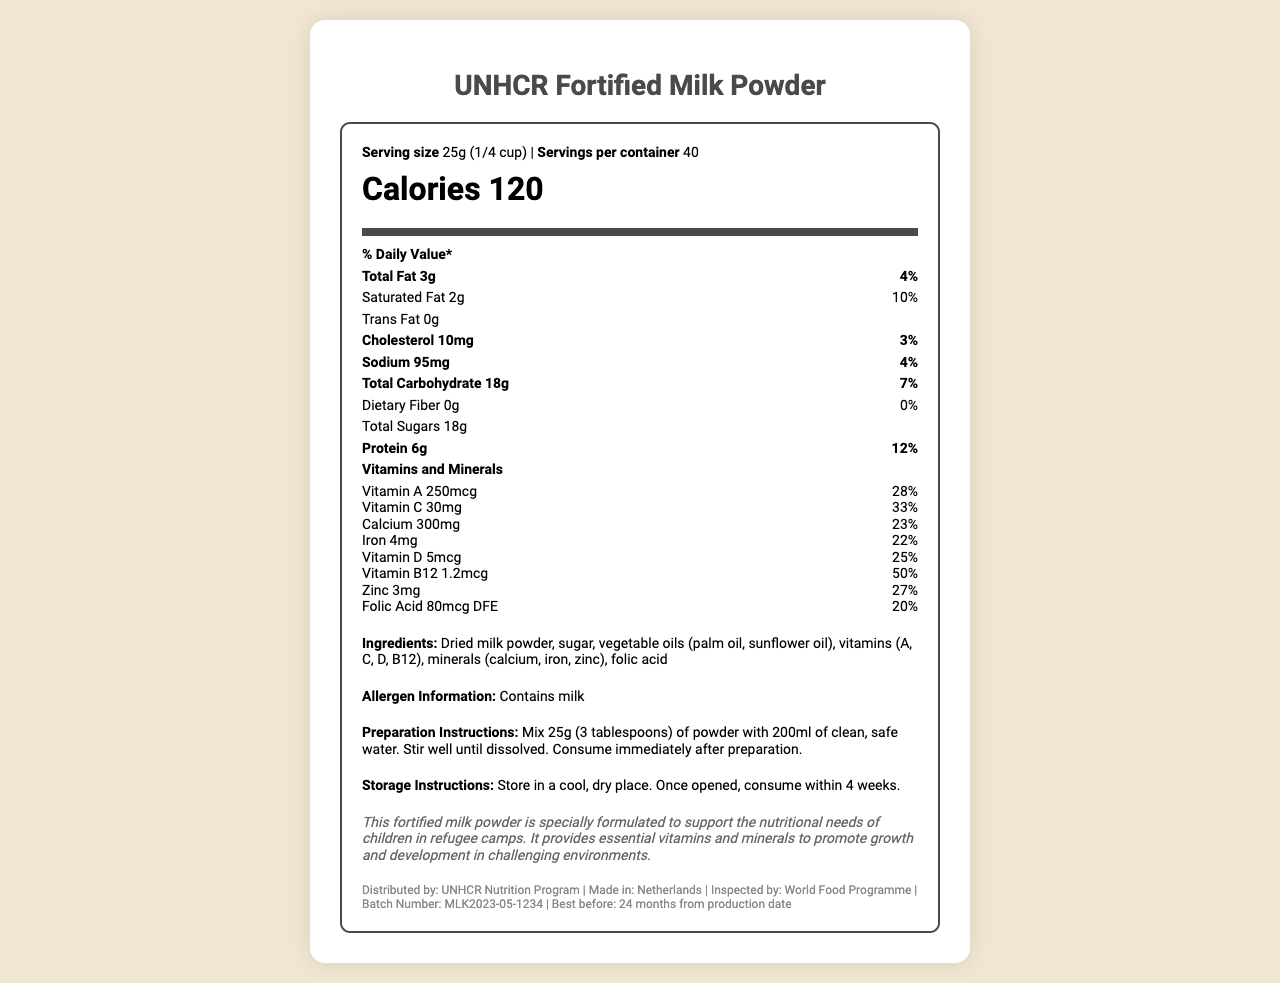what is the serving size of the fortified milk powder? The serving size is clearly listed at the beginning of the label under the "Serving size" information.
Answer: 25g (1/4 cup) how many calories are in one serving of the fortified milk powder? The calories per serving are prominently displayed in a large font size under the "Calories" section of the label.
Answer: 120 how many servings are there per container of this milk powder? The number of servings per container is provided alongside the "Serving size" information at the top of the label.
Answer: 40 what is the daily value percentage of Vitamin C in one serving? The daily value percentage for Vitamin C is listed under the "Vitamins and Minerals" section of the label.
Answer: 33% can you list all the ingredients in the fortified milk powder? The ingredients are detailed in the "Ingredients" section of the label.
Answer: Dried milk powder, sugar, vegetable oils (palm oil, sunflower oil), vitamins (A, C, D, B12), minerals (calcium, iron, zinc), folic acid which of the following nutrients has the highest daily value percentage? A. Calcium B. Iron C. Vitamin B12 D. Folic Acid Vitamin B12 has the highest daily value percentage at 50%, which is clearly listed in the "Vitamins and Minerals" section.
Answer: C. Vitamin B12 how much protein is in one serving of the fortified milk powder? A. 3g B. 6g C. 10mg D. 18g The protein content is listed under the "nutritionFacts" section as 6g per serving with a daily value of 12%.
Answer: B. 6g does this product contain any trans fat? The document explicitly states "Trans Fat 0g" under the "nutritionFacts" section.
Answer: No is this product suitable for someone who is lactose intolerant? The "Allergen Information" section states that the product contains milk.
Answer: No summarize the main purpose of this fortified milk powder. The summary incorporates information from the "productName," "additionalInfo," and the list of nutritional values and vitamins, highlighting its purpose and targeted demographic.
Answer: The fortified milk powder is specially formulated to support the nutritional needs of children in refugee camps, providing essential vitamins and minerals to promote growth and development in challenging environments. what is the production date of this product? The document provides the batch number and expiration date but does not include the production date, hence it cannot be determined from the given information.
Answer: Cannot be determined 